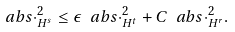<formula> <loc_0><loc_0><loc_500><loc_500>\ a b s { \cdot } _ { H ^ { s } } ^ { 2 } \leq \epsilon \ a b s { \cdot } ^ { 2 } _ { H ^ { t } } + C \ a b s { \cdot } ^ { 2 } _ { H ^ { r } } .</formula> 